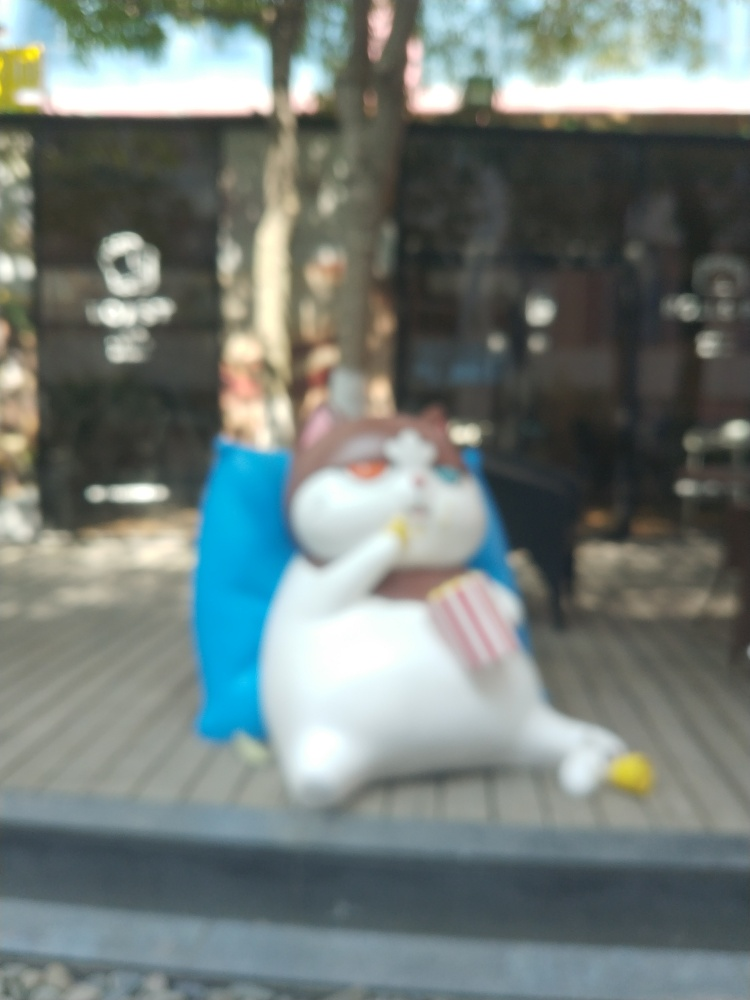How could the quality of this photo be improved? Improving the focus to capture sharper details, ensuring proper lighting, and possibly recomposing the shot to emphasize the subject more would enhance this photo's quality. What is the significance of the object in its hand? It's hard to ascertain the specifics due to the blur, but objects in a statue's hand can represent various themes such as leisure, abundance, or hospitality, depending on cultural context and the object's nature. 